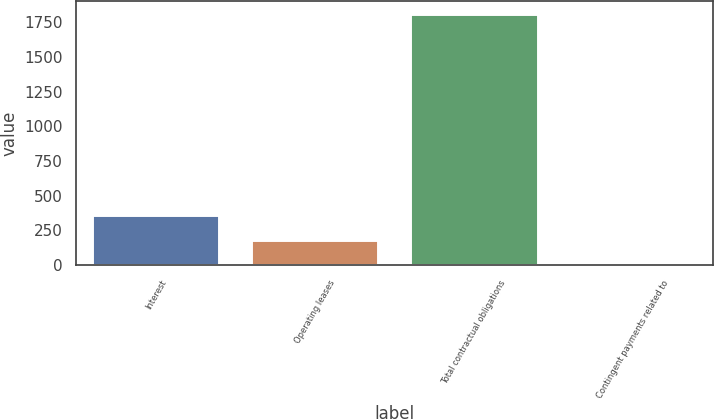Convert chart. <chart><loc_0><loc_0><loc_500><loc_500><bar_chart><fcel>Interest<fcel>Operating leases<fcel>Total contractual obligations<fcel>Contingent payments related to<nl><fcel>364.4<fcel>184.2<fcel>1810.2<fcel>4<nl></chart> 